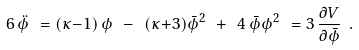Convert formula to latex. <formula><loc_0><loc_0><loc_500><loc_500>6 \, \ddot { \phi } \ = ( \kappa { - } 1 ) \, \phi \ - \ ( \kappa { + } 3 ) { \bar { \phi } } ^ { 2 } \ + \ 4 \, \bar { \phi } \phi ^ { 2 } \ = 3 \, \frac { \partial V } { \partial \bar { \phi } } \ .</formula> 